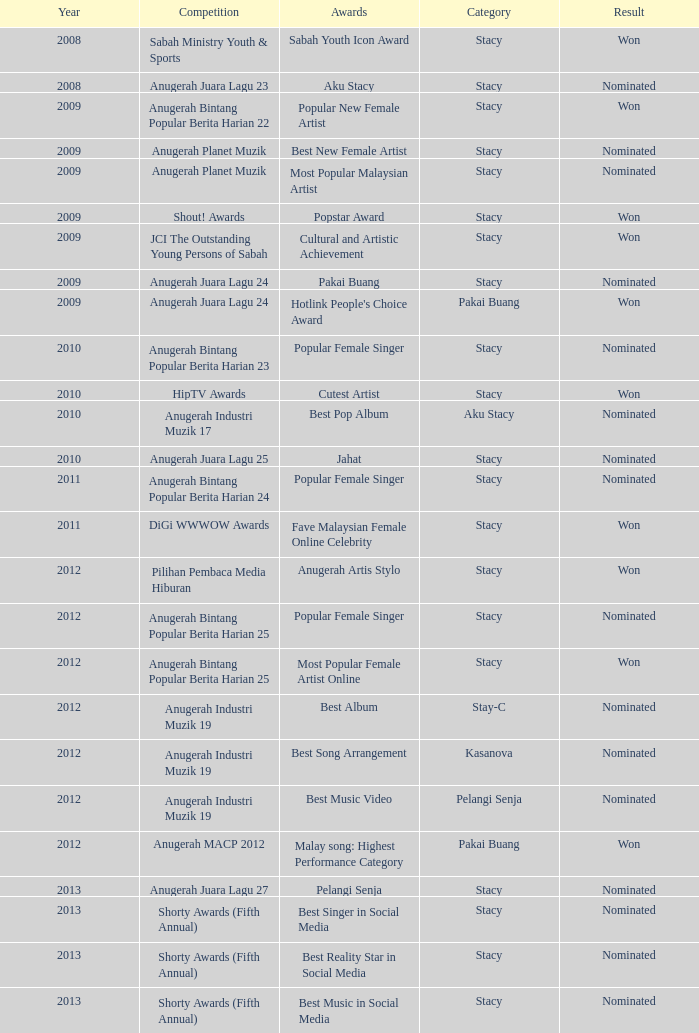What was the year that had Anugerah Bintang Popular Berita Harian 23 as competition? 1.0. 